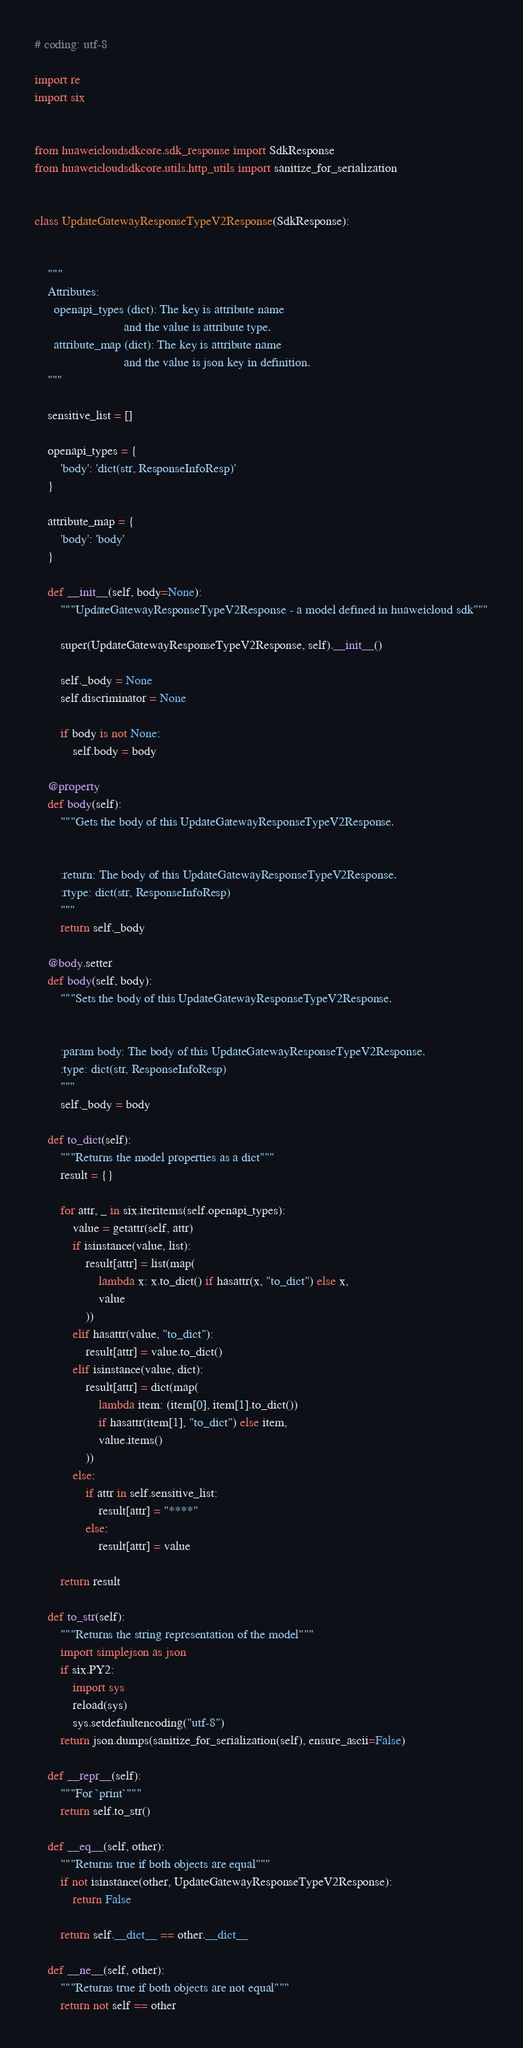Convert code to text. <code><loc_0><loc_0><loc_500><loc_500><_Python_># coding: utf-8

import re
import six


from huaweicloudsdkcore.sdk_response import SdkResponse
from huaweicloudsdkcore.utils.http_utils import sanitize_for_serialization


class UpdateGatewayResponseTypeV2Response(SdkResponse):


    """
    Attributes:
      openapi_types (dict): The key is attribute name
                            and the value is attribute type.
      attribute_map (dict): The key is attribute name
                            and the value is json key in definition.
    """

    sensitive_list = []

    openapi_types = {
        'body': 'dict(str, ResponseInfoResp)'
    }

    attribute_map = {
        'body': 'body'
    }

    def __init__(self, body=None):
        """UpdateGatewayResponseTypeV2Response - a model defined in huaweicloud sdk"""
        
        super(UpdateGatewayResponseTypeV2Response, self).__init__()

        self._body = None
        self.discriminator = None

        if body is not None:
            self.body = body

    @property
    def body(self):
        """Gets the body of this UpdateGatewayResponseTypeV2Response.


        :return: The body of this UpdateGatewayResponseTypeV2Response.
        :rtype: dict(str, ResponseInfoResp)
        """
        return self._body

    @body.setter
    def body(self, body):
        """Sets the body of this UpdateGatewayResponseTypeV2Response.


        :param body: The body of this UpdateGatewayResponseTypeV2Response.
        :type: dict(str, ResponseInfoResp)
        """
        self._body = body

    def to_dict(self):
        """Returns the model properties as a dict"""
        result = {}

        for attr, _ in six.iteritems(self.openapi_types):
            value = getattr(self, attr)
            if isinstance(value, list):
                result[attr] = list(map(
                    lambda x: x.to_dict() if hasattr(x, "to_dict") else x,
                    value
                ))
            elif hasattr(value, "to_dict"):
                result[attr] = value.to_dict()
            elif isinstance(value, dict):
                result[attr] = dict(map(
                    lambda item: (item[0], item[1].to_dict())
                    if hasattr(item[1], "to_dict") else item,
                    value.items()
                ))
            else:
                if attr in self.sensitive_list:
                    result[attr] = "****"
                else:
                    result[attr] = value

        return result

    def to_str(self):
        """Returns the string representation of the model"""
        import simplejson as json
        if six.PY2:
            import sys
            reload(sys)
            sys.setdefaultencoding("utf-8")
        return json.dumps(sanitize_for_serialization(self), ensure_ascii=False)

    def __repr__(self):
        """For `print`"""
        return self.to_str()

    def __eq__(self, other):
        """Returns true if both objects are equal"""
        if not isinstance(other, UpdateGatewayResponseTypeV2Response):
            return False

        return self.__dict__ == other.__dict__

    def __ne__(self, other):
        """Returns true if both objects are not equal"""
        return not self == other
</code> 